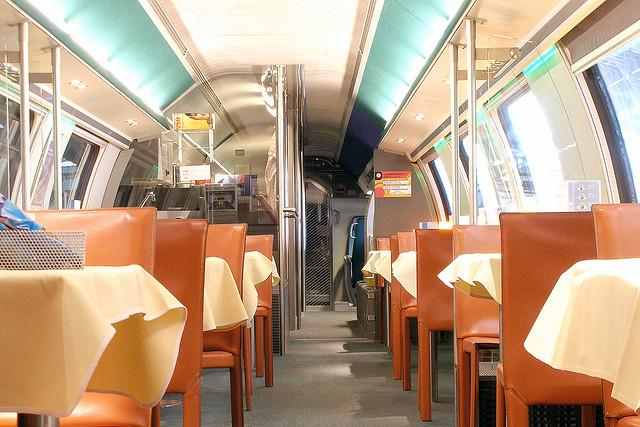Where is this dining room located in all likelihood?

Choices:
A) bus
B) plane
C) train
D) storefront train 